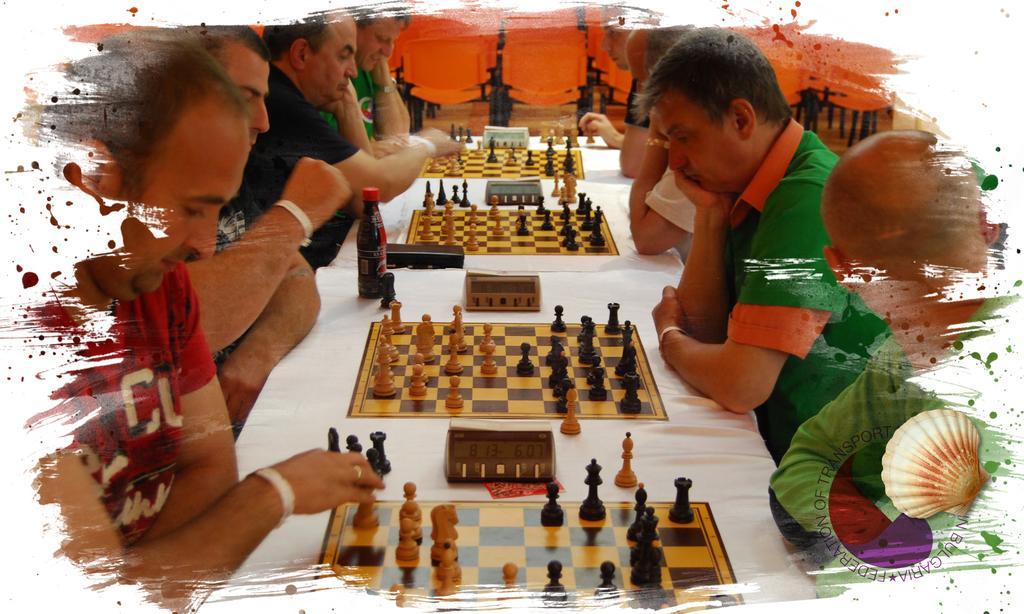In one or two sentences, can you explain what this image depicts? In this picture we can see group of people, they are all seated, in front of them we can find few chess boards and a bottle on the table. 